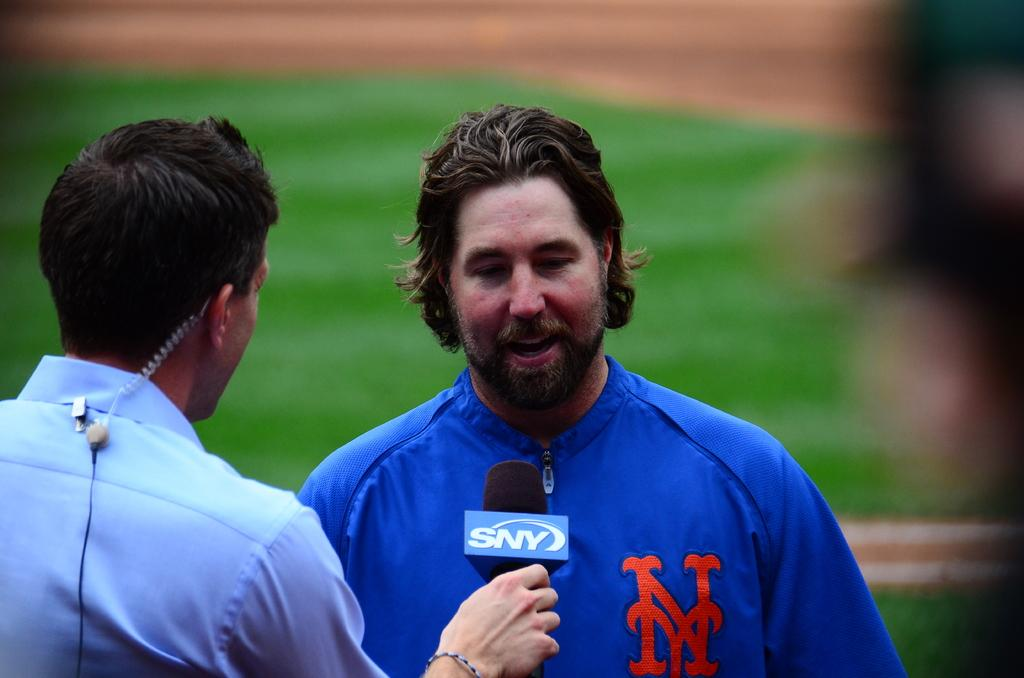Provide a one-sentence caption for the provided image. A man wearing a jacket with NY on it is being interviewed. 